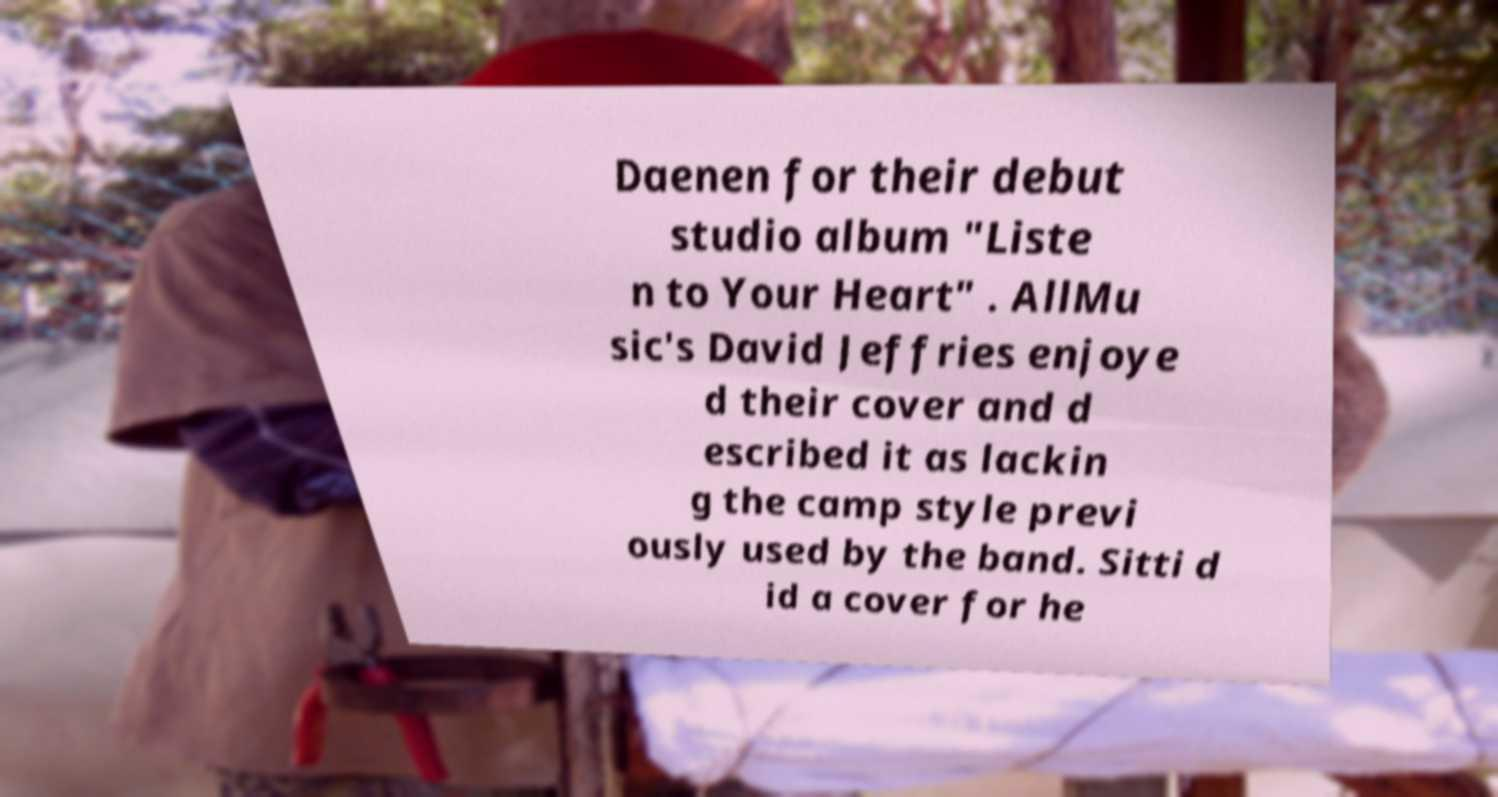What messages or text are displayed in this image? I need them in a readable, typed format. Daenen for their debut studio album "Liste n to Your Heart" . AllMu sic's David Jeffries enjoye d their cover and d escribed it as lackin g the camp style previ ously used by the band. Sitti d id a cover for he 